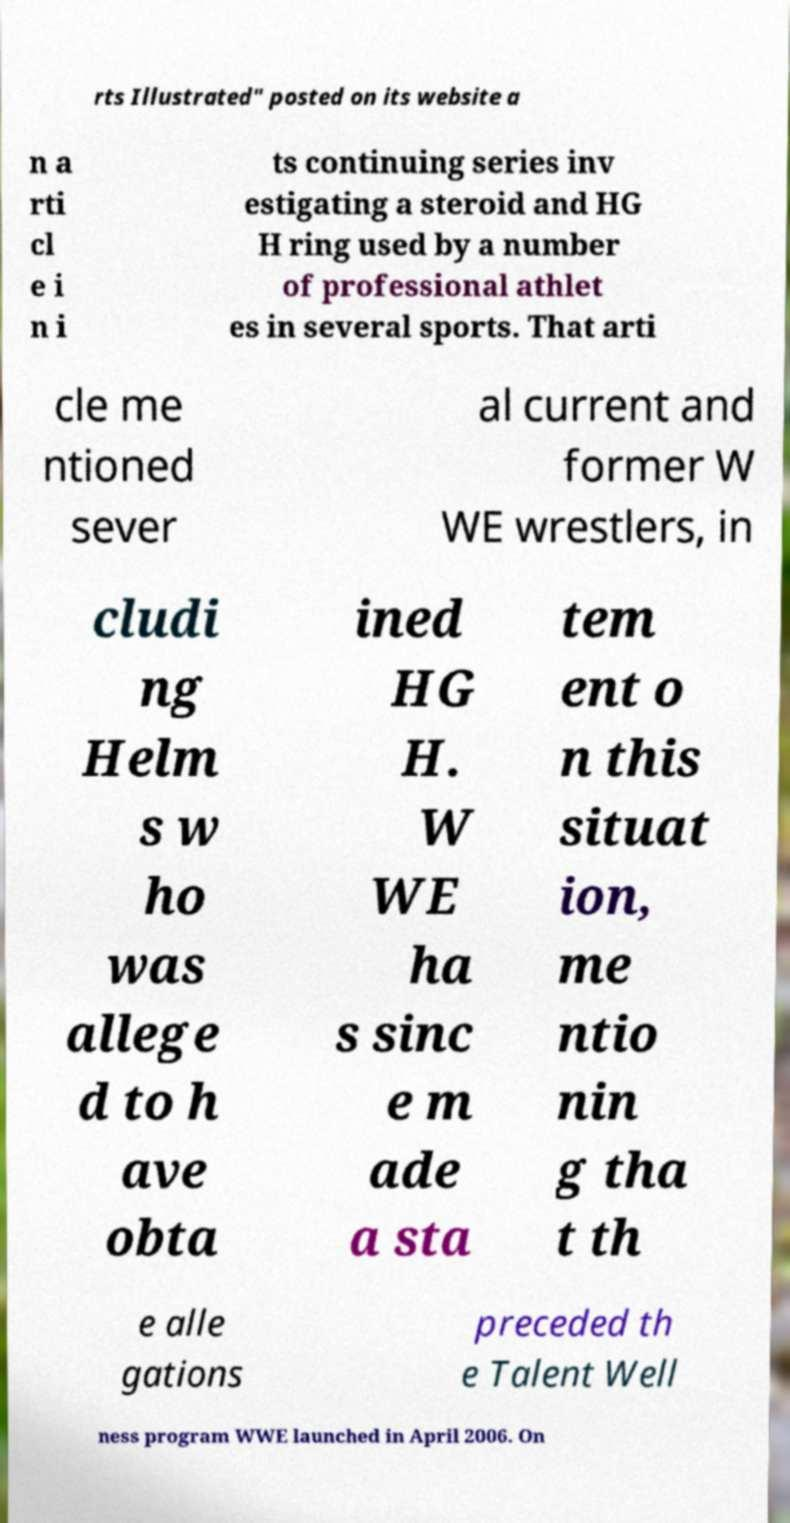Could you extract and type out the text from this image? rts Illustrated" posted on its website a n a rti cl e i n i ts continuing series inv estigating a steroid and HG H ring used by a number of professional athlet es in several sports. That arti cle me ntioned sever al current and former W WE wrestlers, in cludi ng Helm s w ho was allege d to h ave obta ined HG H. W WE ha s sinc e m ade a sta tem ent o n this situat ion, me ntio nin g tha t th e alle gations preceded th e Talent Well ness program WWE launched in April 2006. On 